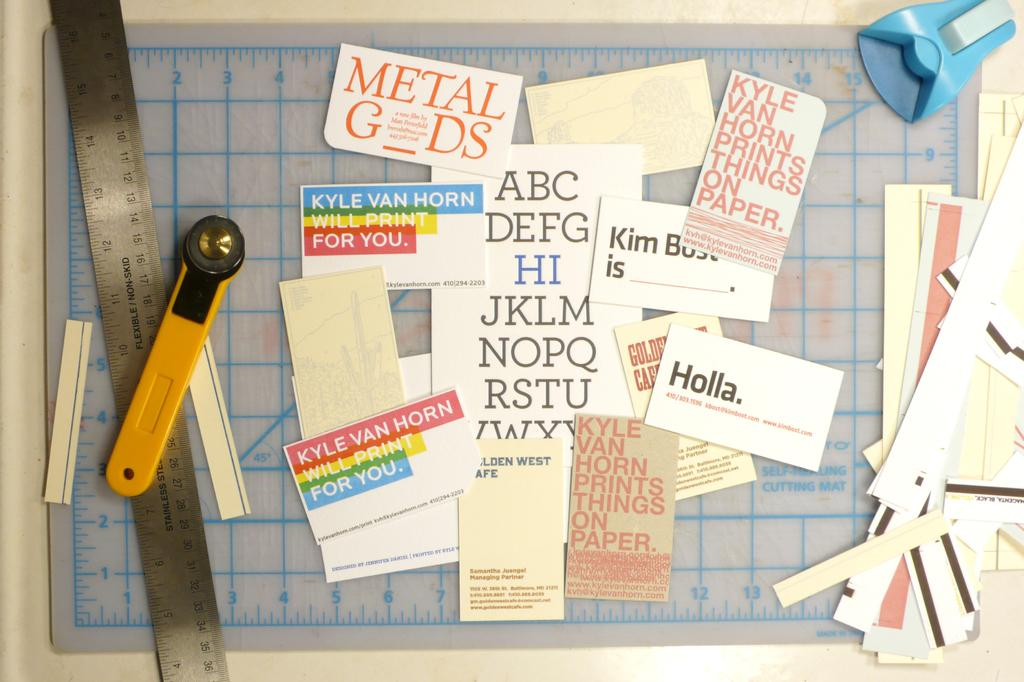<image>
Provide a brief description of the given image. Collage of tiny papers with one saying "Holla." on top of a table. 